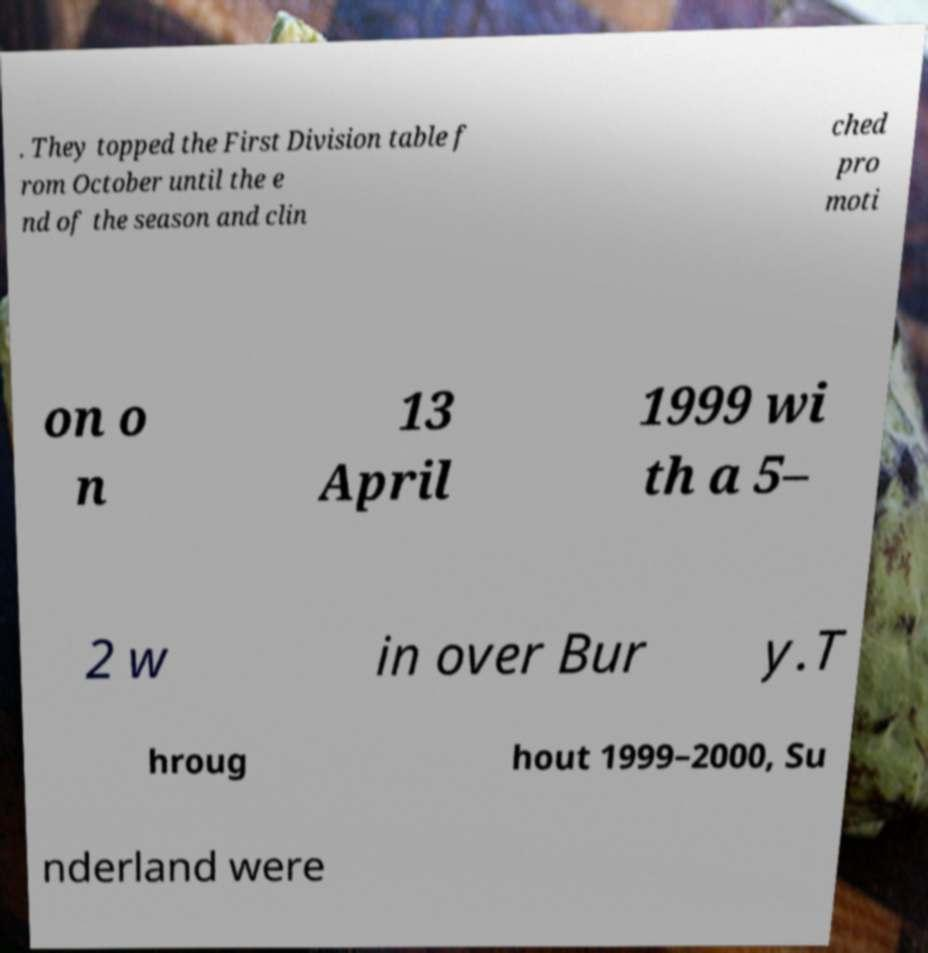There's text embedded in this image that I need extracted. Can you transcribe it verbatim? . They topped the First Division table f rom October until the e nd of the season and clin ched pro moti on o n 13 April 1999 wi th a 5– 2 w in over Bur y.T hroug hout 1999–2000, Su nderland were 